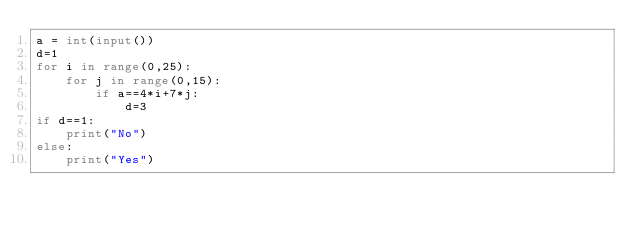Convert code to text. <code><loc_0><loc_0><loc_500><loc_500><_Python_>a = int(input())
d=1
for i in range(0,25):
    for j in range(0,15):
        if a==4*i+7*j:
            d=3
if d==1:
    print("No")
else:
    print("Yes")
            </code> 